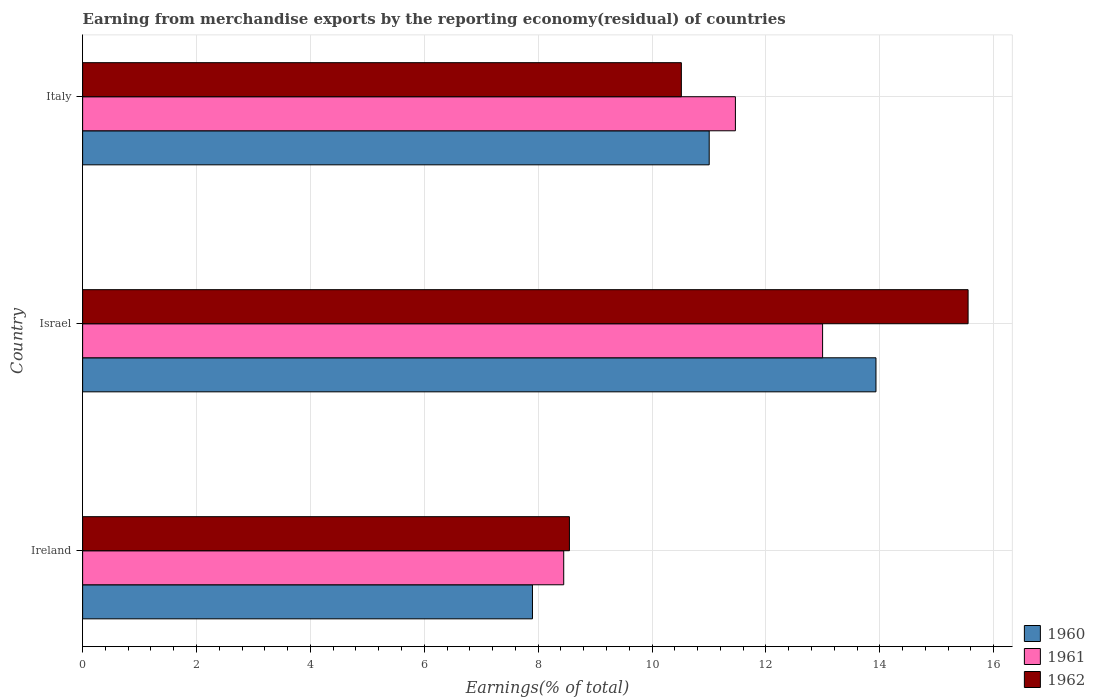Are the number of bars per tick equal to the number of legend labels?
Give a very brief answer. Yes. Are the number of bars on each tick of the Y-axis equal?
Offer a very short reply. Yes. In how many cases, is the number of bars for a given country not equal to the number of legend labels?
Keep it short and to the point. 0. What is the percentage of amount earned from merchandise exports in 1961 in Israel?
Your response must be concise. 13. Across all countries, what is the maximum percentage of amount earned from merchandise exports in 1960?
Give a very brief answer. 13.93. Across all countries, what is the minimum percentage of amount earned from merchandise exports in 1961?
Provide a succinct answer. 8.45. In which country was the percentage of amount earned from merchandise exports in 1962 minimum?
Make the answer very short. Ireland. What is the total percentage of amount earned from merchandise exports in 1962 in the graph?
Offer a very short reply. 34.61. What is the difference between the percentage of amount earned from merchandise exports in 1961 in Israel and that in Italy?
Offer a terse response. 1.53. What is the difference between the percentage of amount earned from merchandise exports in 1962 in Israel and the percentage of amount earned from merchandise exports in 1960 in Italy?
Your answer should be compact. 4.55. What is the average percentage of amount earned from merchandise exports in 1962 per country?
Give a very brief answer. 11.54. What is the difference between the percentage of amount earned from merchandise exports in 1961 and percentage of amount earned from merchandise exports in 1960 in Israel?
Provide a short and direct response. -0.94. In how many countries, is the percentage of amount earned from merchandise exports in 1961 greater than 5.2 %?
Your answer should be very brief. 3. What is the ratio of the percentage of amount earned from merchandise exports in 1961 in Israel to that in Italy?
Give a very brief answer. 1.13. Is the percentage of amount earned from merchandise exports in 1961 in Israel less than that in Italy?
Ensure brevity in your answer.  No. What is the difference between the highest and the second highest percentage of amount earned from merchandise exports in 1962?
Your answer should be compact. 5.04. What is the difference between the highest and the lowest percentage of amount earned from merchandise exports in 1962?
Keep it short and to the point. 7. In how many countries, is the percentage of amount earned from merchandise exports in 1960 greater than the average percentage of amount earned from merchandise exports in 1960 taken over all countries?
Provide a short and direct response. 2. How many bars are there?
Provide a succinct answer. 9. How many countries are there in the graph?
Offer a very short reply. 3. Where does the legend appear in the graph?
Your answer should be compact. Bottom right. How many legend labels are there?
Offer a very short reply. 3. How are the legend labels stacked?
Provide a short and direct response. Vertical. What is the title of the graph?
Keep it short and to the point. Earning from merchandise exports by the reporting economy(residual) of countries. What is the label or title of the X-axis?
Offer a terse response. Earnings(% of total). What is the label or title of the Y-axis?
Ensure brevity in your answer.  Country. What is the Earnings(% of total) in 1960 in Ireland?
Offer a terse response. 7.9. What is the Earnings(% of total) in 1961 in Ireland?
Provide a succinct answer. 8.45. What is the Earnings(% of total) of 1962 in Ireland?
Your response must be concise. 8.55. What is the Earnings(% of total) of 1960 in Israel?
Your answer should be compact. 13.93. What is the Earnings(% of total) in 1961 in Israel?
Give a very brief answer. 13. What is the Earnings(% of total) of 1962 in Israel?
Keep it short and to the point. 15.55. What is the Earnings(% of total) of 1960 in Italy?
Provide a short and direct response. 11. What is the Earnings(% of total) in 1961 in Italy?
Give a very brief answer. 11.46. What is the Earnings(% of total) in 1962 in Italy?
Your answer should be compact. 10.52. Across all countries, what is the maximum Earnings(% of total) of 1960?
Your answer should be compact. 13.93. Across all countries, what is the maximum Earnings(% of total) of 1961?
Keep it short and to the point. 13. Across all countries, what is the maximum Earnings(% of total) of 1962?
Provide a succinct answer. 15.55. Across all countries, what is the minimum Earnings(% of total) in 1960?
Give a very brief answer. 7.9. Across all countries, what is the minimum Earnings(% of total) of 1961?
Provide a succinct answer. 8.45. Across all countries, what is the minimum Earnings(% of total) in 1962?
Make the answer very short. 8.55. What is the total Earnings(% of total) of 1960 in the graph?
Your answer should be compact. 32.84. What is the total Earnings(% of total) of 1961 in the graph?
Your answer should be compact. 32.91. What is the total Earnings(% of total) of 1962 in the graph?
Ensure brevity in your answer.  34.61. What is the difference between the Earnings(% of total) of 1960 in Ireland and that in Israel?
Your response must be concise. -6.03. What is the difference between the Earnings(% of total) of 1961 in Ireland and that in Israel?
Your answer should be very brief. -4.55. What is the difference between the Earnings(% of total) in 1962 in Ireland and that in Israel?
Provide a succinct answer. -7. What is the difference between the Earnings(% of total) of 1960 in Ireland and that in Italy?
Offer a very short reply. -3.1. What is the difference between the Earnings(% of total) of 1961 in Ireland and that in Italy?
Keep it short and to the point. -3.02. What is the difference between the Earnings(% of total) of 1962 in Ireland and that in Italy?
Give a very brief answer. -1.97. What is the difference between the Earnings(% of total) in 1960 in Israel and that in Italy?
Ensure brevity in your answer.  2.93. What is the difference between the Earnings(% of total) in 1961 in Israel and that in Italy?
Provide a short and direct response. 1.53. What is the difference between the Earnings(% of total) in 1962 in Israel and that in Italy?
Your response must be concise. 5.04. What is the difference between the Earnings(% of total) in 1960 in Ireland and the Earnings(% of total) in 1961 in Israel?
Your response must be concise. -5.1. What is the difference between the Earnings(% of total) of 1960 in Ireland and the Earnings(% of total) of 1962 in Israel?
Your answer should be very brief. -7.65. What is the difference between the Earnings(% of total) of 1961 in Ireland and the Earnings(% of total) of 1962 in Israel?
Give a very brief answer. -7.1. What is the difference between the Earnings(% of total) of 1960 in Ireland and the Earnings(% of total) of 1961 in Italy?
Your response must be concise. -3.56. What is the difference between the Earnings(% of total) of 1960 in Ireland and the Earnings(% of total) of 1962 in Italy?
Your answer should be very brief. -2.61. What is the difference between the Earnings(% of total) in 1961 in Ireland and the Earnings(% of total) in 1962 in Italy?
Keep it short and to the point. -2.07. What is the difference between the Earnings(% of total) in 1960 in Israel and the Earnings(% of total) in 1961 in Italy?
Provide a succinct answer. 2.47. What is the difference between the Earnings(% of total) of 1960 in Israel and the Earnings(% of total) of 1962 in Italy?
Provide a succinct answer. 3.42. What is the difference between the Earnings(% of total) in 1961 in Israel and the Earnings(% of total) in 1962 in Italy?
Offer a terse response. 2.48. What is the average Earnings(% of total) in 1960 per country?
Your response must be concise. 10.95. What is the average Earnings(% of total) in 1961 per country?
Keep it short and to the point. 10.97. What is the average Earnings(% of total) of 1962 per country?
Keep it short and to the point. 11.54. What is the difference between the Earnings(% of total) in 1960 and Earnings(% of total) in 1961 in Ireland?
Ensure brevity in your answer.  -0.55. What is the difference between the Earnings(% of total) of 1960 and Earnings(% of total) of 1962 in Ireland?
Provide a short and direct response. -0.65. What is the difference between the Earnings(% of total) in 1961 and Earnings(% of total) in 1962 in Ireland?
Make the answer very short. -0.1. What is the difference between the Earnings(% of total) of 1960 and Earnings(% of total) of 1961 in Israel?
Make the answer very short. 0.94. What is the difference between the Earnings(% of total) of 1960 and Earnings(% of total) of 1962 in Israel?
Keep it short and to the point. -1.62. What is the difference between the Earnings(% of total) in 1961 and Earnings(% of total) in 1962 in Israel?
Offer a very short reply. -2.56. What is the difference between the Earnings(% of total) of 1960 and Earnings(% of total) of 1961 in Italy?
Keep it short and to the point. -0.46. What is the difference between the Earnings(% of total) in 1960 and Earnings(% of total) in 1962 in Italy?
Keep it short and to the point. 0.49. What is the difference between the Earnings(% of total) in 1961 and Earnings(% of total) in 1962 in Italy?
Your answer should be compact. 0.95. What is the ratio of the Earnings(% of total) of 1960 in Ireland to that in Israel?
Your answer should be compact. 0.57. What is the ratio of the Earnings(% of total) of 1961 in Ireland to that in Israel?
Your response must be concise. 0.65. What is the ratio of the Earnings(% of total) in 1962 in Ireland to that in Israel?
Provide a short and direct response. 0.55. What is the ratio of the Earnings(% of total) in 1960 in Ireland to that in Italy?
Keep it short and to the point. 0.72. What is the ratio of the Earnings(% of total) in 1961 in Ireland to that in Italy?
Provide a succinct answer. 0.74. What is the ratio of the Earnings(% of total) in 1962 in Ireland to that in Italy?
Provide a succinct answer. 0.81. What is the ratio of the Earnings(% of total) in 1960 in Israel to that in Italy?
Your answer should be very brief. 1.27. What is the ratio of the Earnings(% of total) of 1961 in Israel to that in Italy?
Make the answer very short. 1.13. What is the ratio of the Earnings(% of total) of 1962 in Israel to that in Italy?
Keep it short and to the point. 1.48. What is the difference between the highest and the second highest Earnings(% of total) in 1960?
Your answer should be very brief. 2.93. What is the difference between the highest and the second highest Earnings(% of total) in 1961?
Ensure brevity in your answer.  1.53. What is the difference between the highest and the second highest Earnings(% of total) of 1962?
Your answer should be compact. 5.04. What is the difference between the highest and the lowest Earnings(% of total) in 1960?
Your response must be concise. 6.03. What is the difference between the highest and the lowest Earnings(% of total) in 1961?
Give a very brief answer. 4.55. What is the difference between the highest and the lowest Earnings(% of total) in 1962?
Provide a short and direct response. 7. 